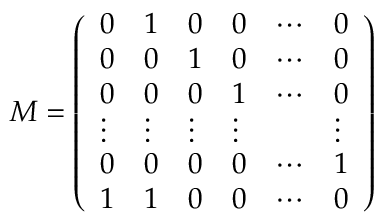<formula> <loc_0><loc_0><loc_500><loc_500>M = \left ( { \begin{array} { l l l l l l } { 0 } & { 1 } & { 0 } & { 0 } & { \cdots } & { 0 } \\ { 0 } & { 0 } & { 1 } & { 0 } & { \cdots } & { 0 } \\ { 0 } & { 0 } & { 0 } & { 1 } & { \cdots } & { 0 } \\ { \vdots } & { \vdots } & { \vdots } & { \vdots } & & { \vdots } \\ { 0 } & { 0 } & { 0 } & { 0 } & { \cdots } & { 1 } \\ { 1 } & { 1 } & { 0 } & { 0 } & { \cdots } & { 0 } \end{array} } \right )</formula> 